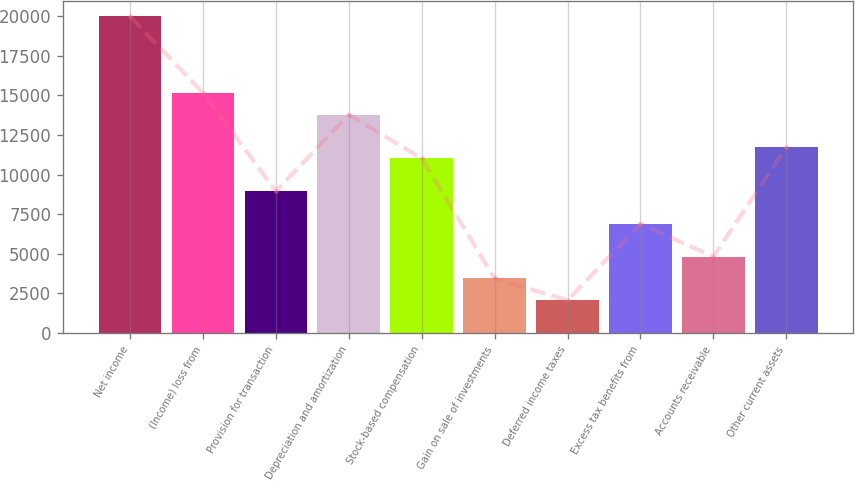Convert chart to OTSL. <chart><loc_0><loc_0><loc_500><loc_500><bar_chart><fcel>Net income<fcel>(Income) loss from<fcel>Provision for transaction<fcel>Depreciation and amortization<fcel>Stock-based compensation<fcel>Gain on sale of investments<fcel>Deferred income taxes<fcel>Excess tax benefits from<fcel>Accounts receivable<fcel>Other current assets<nl><fcel>19974.3<fcel>15153.4<fcel>8955.1<fcel>13776<fcel>11021.2<fcel>3445.5<fcel>2068.1<fcel>6889<fcel>4822.9<fcel>11709.9<nl></chart> 